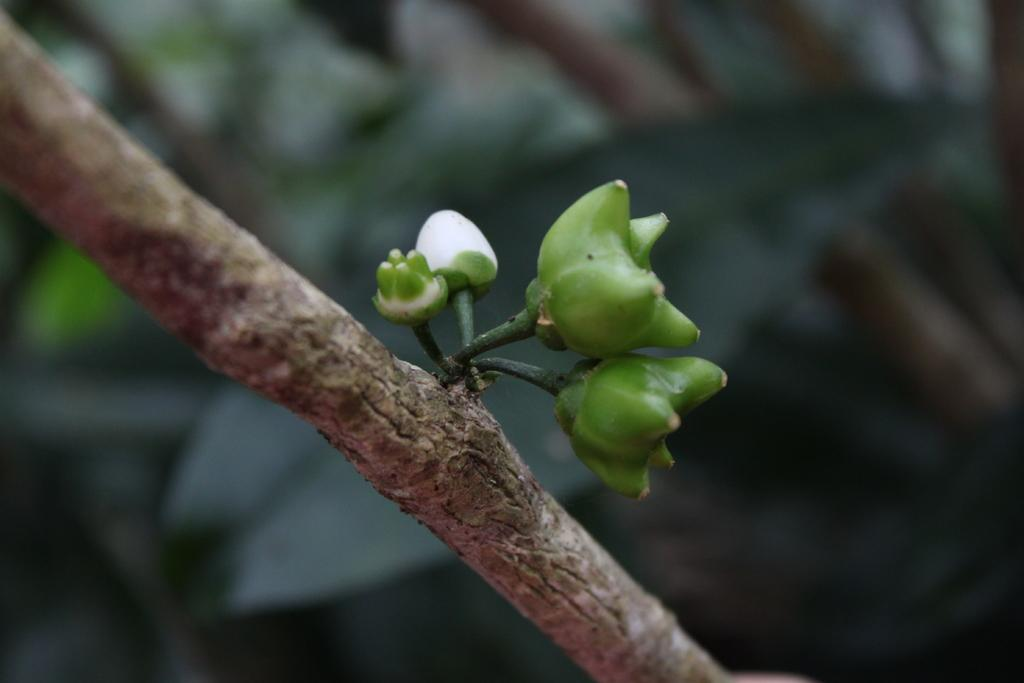What is present on the branch in the image? There are buds on a branch in the image. Can you describe the background of the image? The background of the image is blurred. What type of oven can be seen in the image? There is no oven present in the image; it features buds on a branch with a blurred background. 